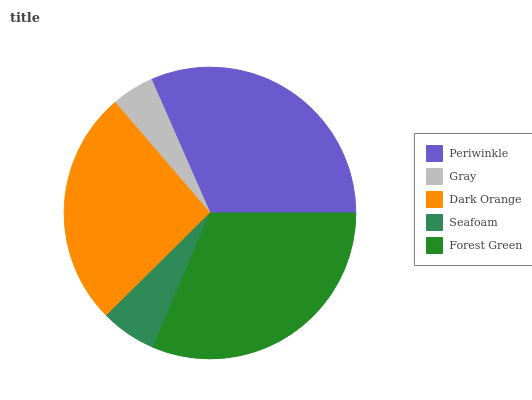Is Gray the minimum?
Answer yes or no. Yes. Is Periwinkle the maximum?
Answer yes or no. Yes. Is Dark Orange the minimum?
Answer yes or no. No. Is Dark Orange the maximum?
Answer yes or no. No. Is Dark Orange greater than Gray?
Answer yes or no. Yes. Is Gray less than Dark Orange?
Answer yes or no. Yes. Is Gray greater than Dark Orange?
Answer yes or no. No. Is Dark Orange less than Gray?
Answer yes or no. No. Is Dark Orange the high median?
Answer yes or no. Yes. Is Dark Orange the low median?
Answer yes or no. Yes. Is Gray the high median?
Answer yes or no. No. Is Periwinkle the low median?
Answer yes or no. No. 